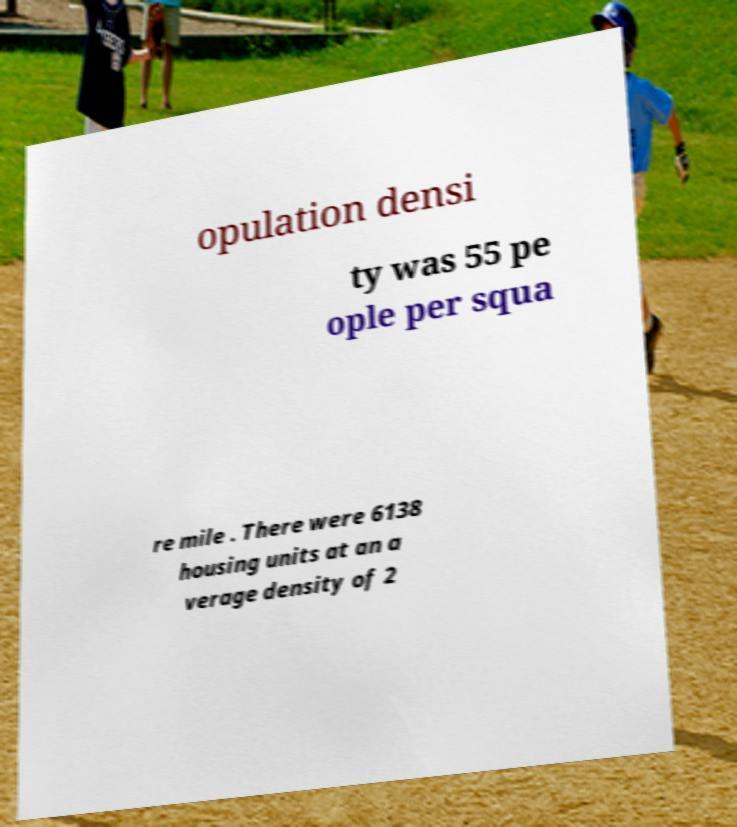Could you extract and type out the text from this image? opulation densi ty was 55 pe ople per squa re mile . There were 6138 housing units at an a verage density of 2 